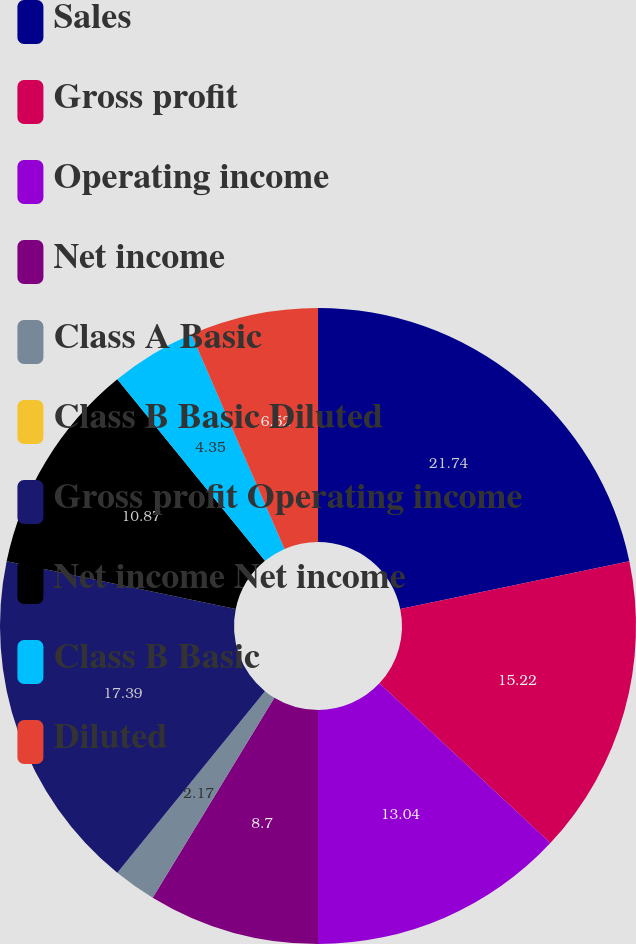Convert chart. <chart><loc_0><loc_0><loc_500><loc_500><pie_chart><fcel>Sales<fcel>Gross profit<fcel>Operating income<fcel>Net income<fcel>Class A Basic<fcel>Class B Basic Diluted<fcel>Gross profit Operating income<fcel>Net income Net income<fcel>Class B Basic<fcel>Diluted<nl><fcel>21.74%<fcel>15.22%<fcel>13.04%<fcel>8.7%<fcel>2.17%<fcel>0.0%<fcel>17.39%<fcel>10.87%<fcel>4.35%<fcel>6.52%<nl></chart> 